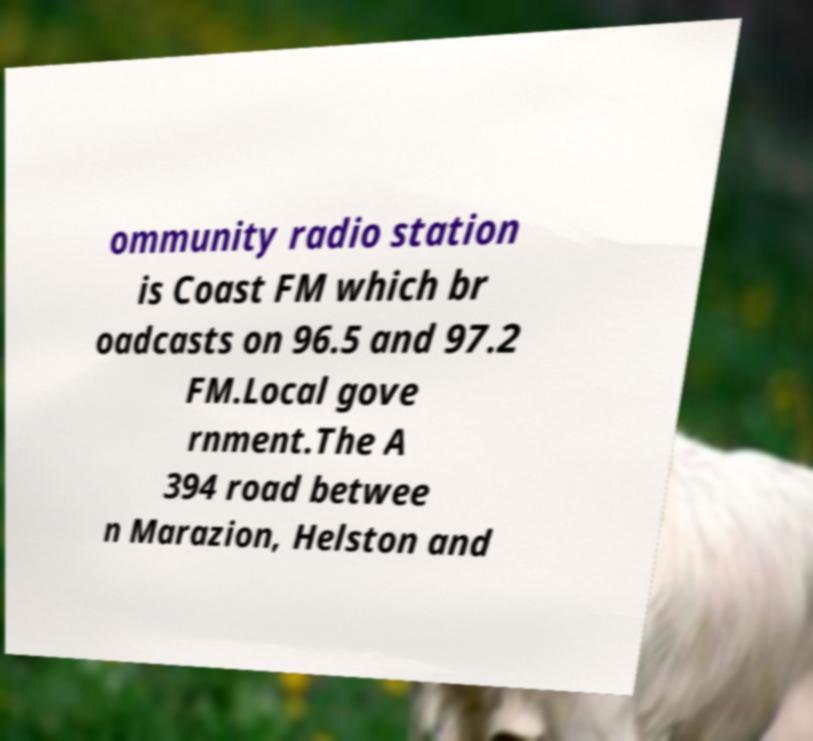Can you accurately transcribe the text from the provided image for me? ommunity radio station is Coast FM which br oadcasts on 96.5 and 97.2 FM.Local gove rnment.The A 394 road betwee n Marazion, Helston and 